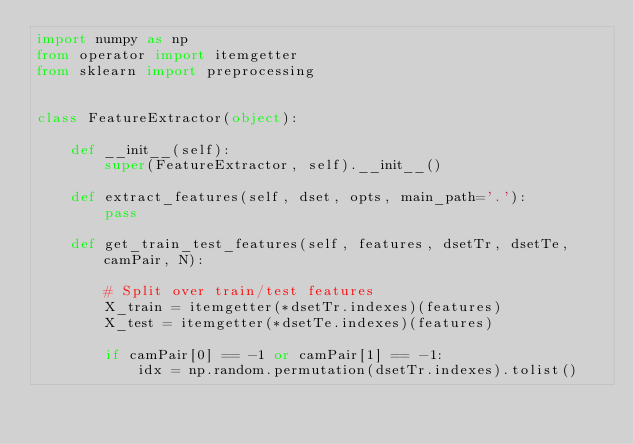<code> <loc_0><loc_0><loc_500><loc_500><_Python_>import numpy as np
from operator import itemgetter
from sklearn import preprocessing


class FeatureExtractor(object):

    def __init__(self):
        super(FeatureExtractor, self).__init__()

    def extract_features(self, dset, opts, main_path='.'):
        pass

    def get_train_test_features(self, features, dsetTr, dsetTe, camPair, N):

        # Split over train/test features
        X_train = itemgetter(*dsetTr.indexes)(features)
        X_test = itemgetter(*dsetTe.indexes)(features)

        if camPair[0] == -1 or camPair[1] == -1:
            idx = np.random.permutation(dsetTr.indexes).tolist()</code> 